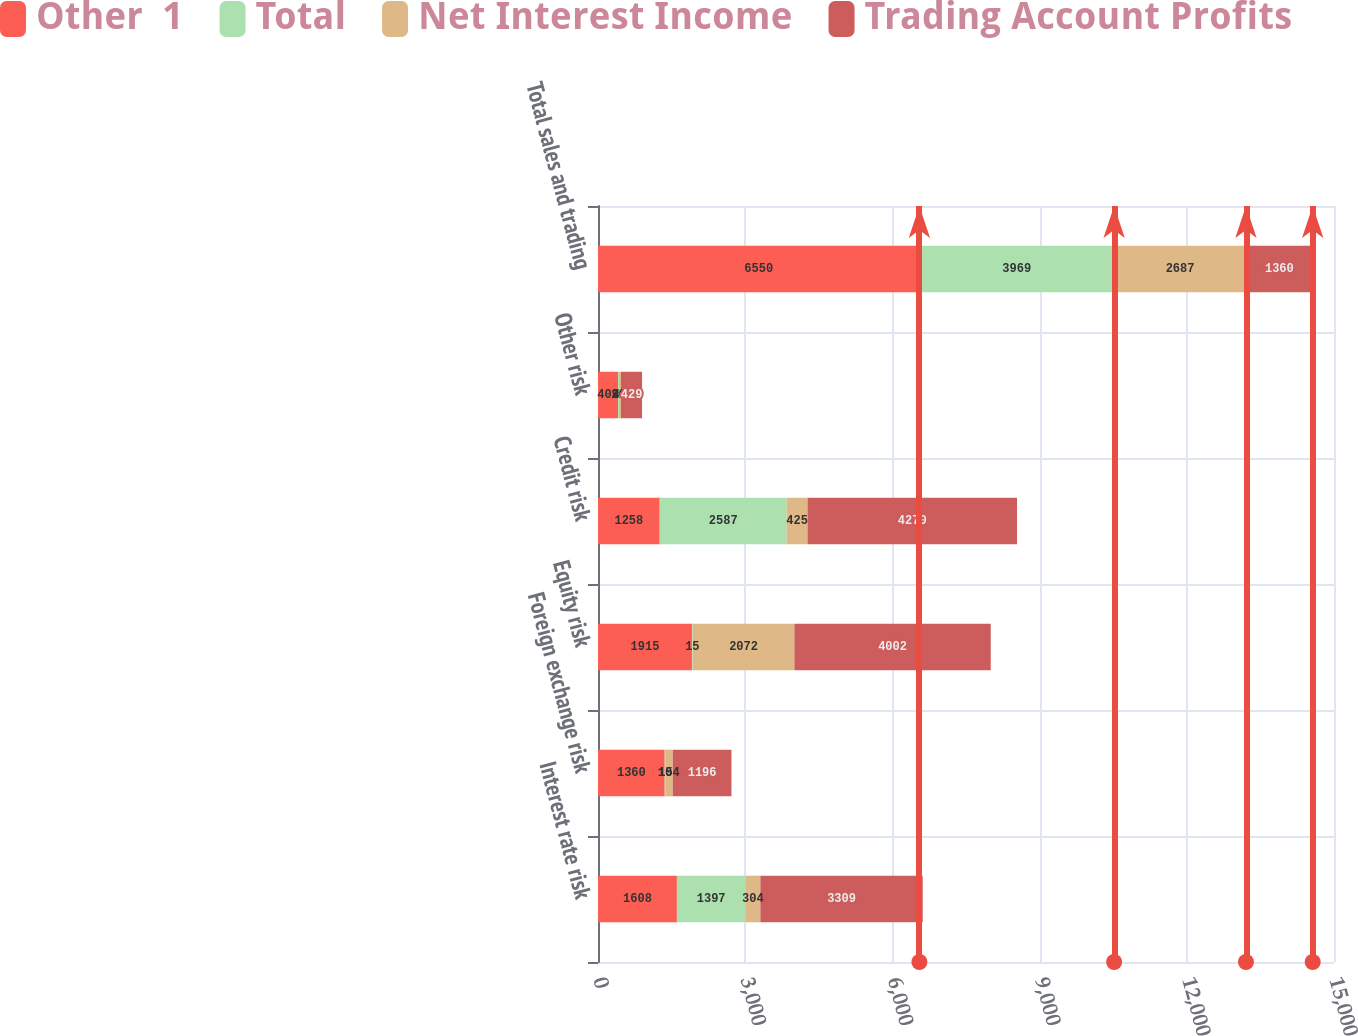<chart> <loc_0><loc_0><loc_500><loc_500><stacked_bar_chart><ecel><fcel>Interest rate risk<fcel>Foreign exchange risk<fcel>Equity risk<fcel>Credit risk<fcel>Other risk<fcel>Total sales and trading<nl><fcel>Other  1<fcel>1608<fcel>1360<fcel>1915<fcel>1258<fcel>409<fcel>6550<nl><fcel>Total<fcel>1397<fcel>10<fcel>15<fcel>2587<fcel>20<fcel>3969<nl><fcel>Net Interest Income<fcel>304<fcel>154<fcel>2072<fcel>425<fcel>40<fcel>2687<nl><fcel>Trading Account Profits<fcel>3309<fcel>1196<fcel>4002<fcel>4270<fcel>429<fcel>1360<nl></chart> 